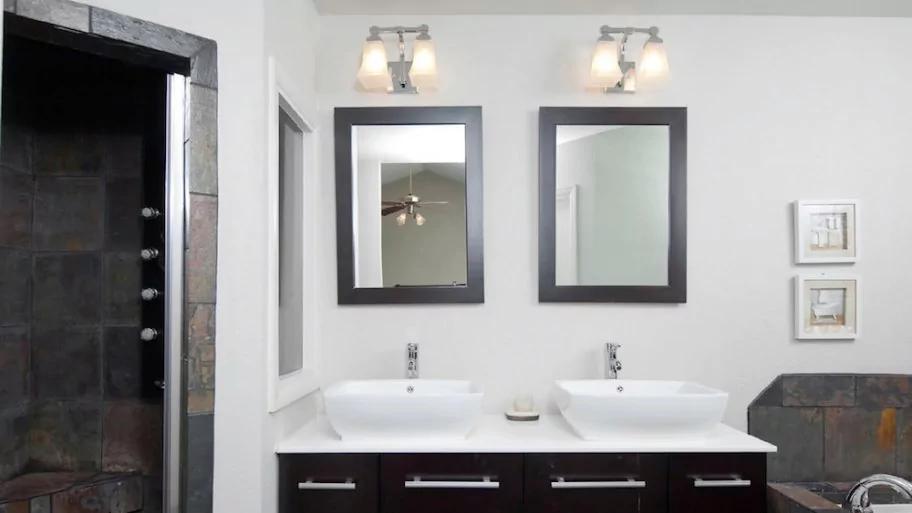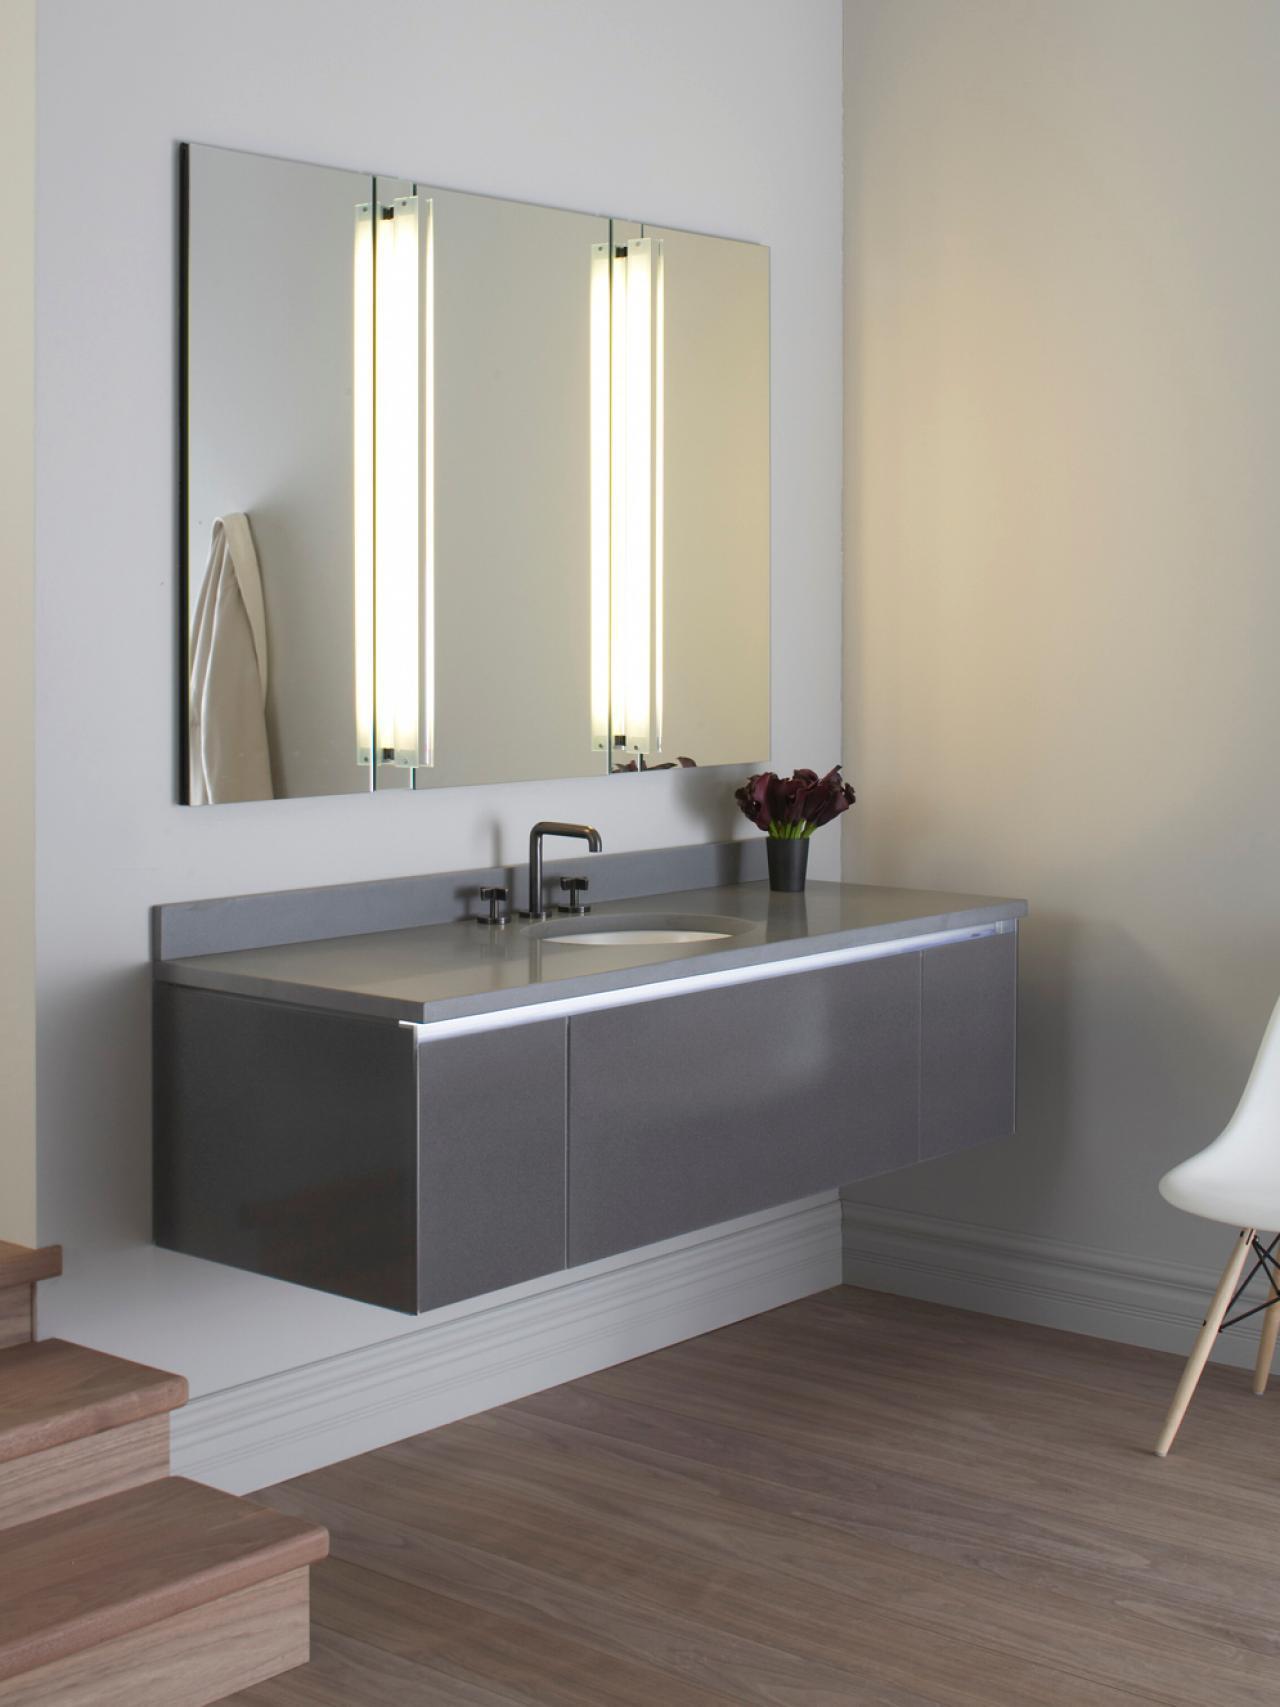The first image is the image on the left, the second image is the image on the right. Analyze the images presented: Is the assertion "One picture has mirrors with black borders" valid? Answer yes or no. Yes. The first image is the image on the left, the second image is the image on the right. Examine the images to the left and right. Is the description "A bathroom features two black-framed rectangular mirrors over a double-sink vaniety with a black cabinet." accurate? Answer yes or no. Yes. 